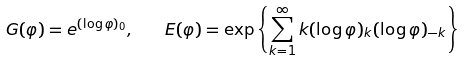<formula> <loc_0><loc_0><loc_500><loc_500>G ( \varphi ) = e ^ { ( \log \varphi ) _ { 0 } } , \quad E ( \varphi ) = \exp \left \{ \sum _ { k = 1 } ^ { \infty } k ( \log \varphi ) _ { k } ( \log \varphi ) _ { - k } \right \}</formula> 